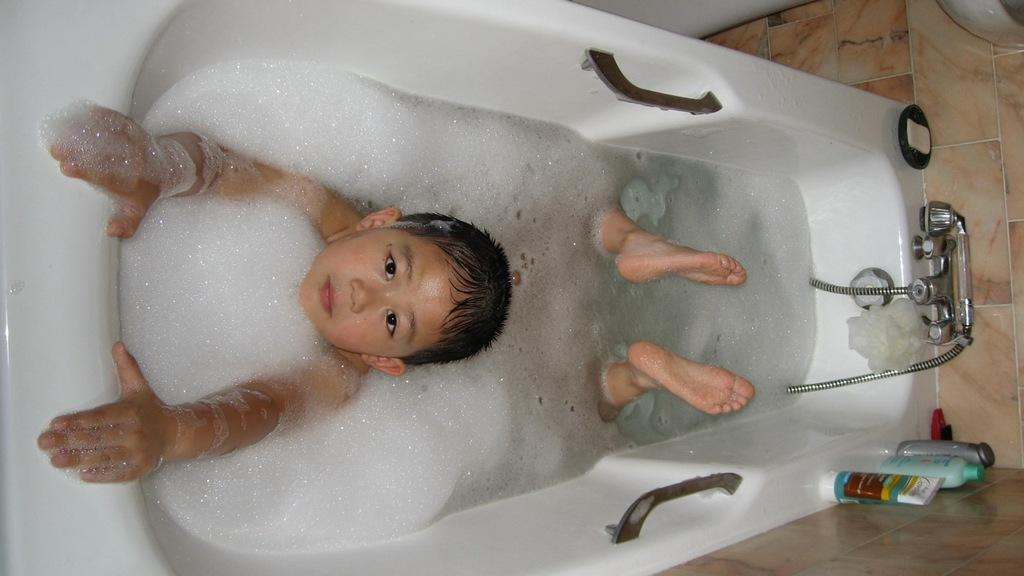What is the boy doing in the image? The boy is lying in the tub water. Are there any objects placed near the boy? Yes, there are bottles placed on the bath tub. Where is the hen located in the image? There is no hen present in the image. What type of basin is being used for the meeting in the image? There is no meeting or basin present in the image. 